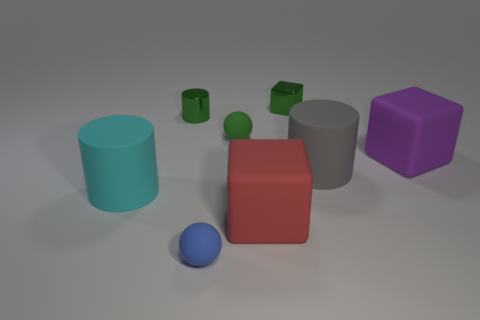What is the size of the rubber object that is to the left of the small green matte ball and behind the blue object?
Your answer should be very brief. Large. What number of objects are small gray cylinders or spheres?
Keep it short and to the point. 2. There is a cyan rubber cylinder; is it the same size as the ball that is in front of the gray cylinder?
Your response must be concise. No. There is a matte block that is in front of the large block to the right of the rubber cylinder to the right of the red rubber block; what is its size?
Provide a short and direct response. Large. Are any big cyan objects visible?
Your answer should be compact. Yes. There is a cylinder that is the same color as the tiny metallic block; what is it made of?
Offer a terse response. Metal. What number of large things are the same color as the small cylinder?
Keep it short and to the point. 0. What number of objects are either tiny green objects behind the small blue rubber ball or matte things left of the tiny green shiny cylinder?
Give a very brief answer. 4. How many things are in front of the matte cube that is on the right side of the gray cylinder?
Ensure brevity in your answer.  4. What is the color of the large cube that is the same material as the large purple object?
Offer a very short reply. Red. 